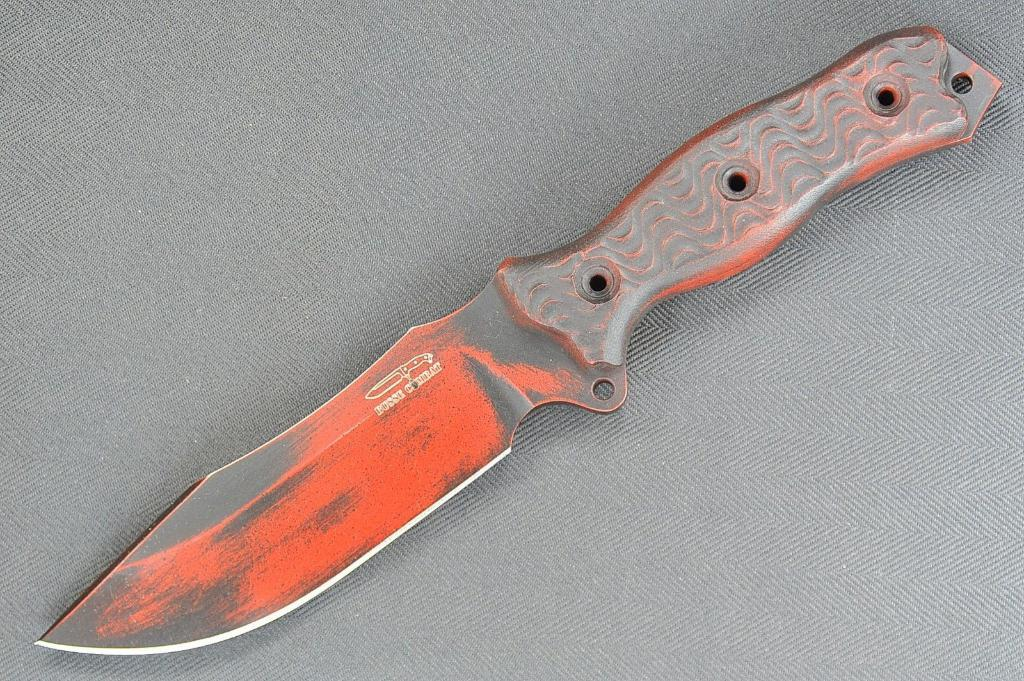What object is located in the center of the image? The knife is in the center of the image. What is the color of the knife? The knife is red in color. What type of party is being held in the image? There is no party present in the image; it only features a red knife in the center. How many ranges can be seen in the image? There are no ranges present in the image; it only features a red knife. 